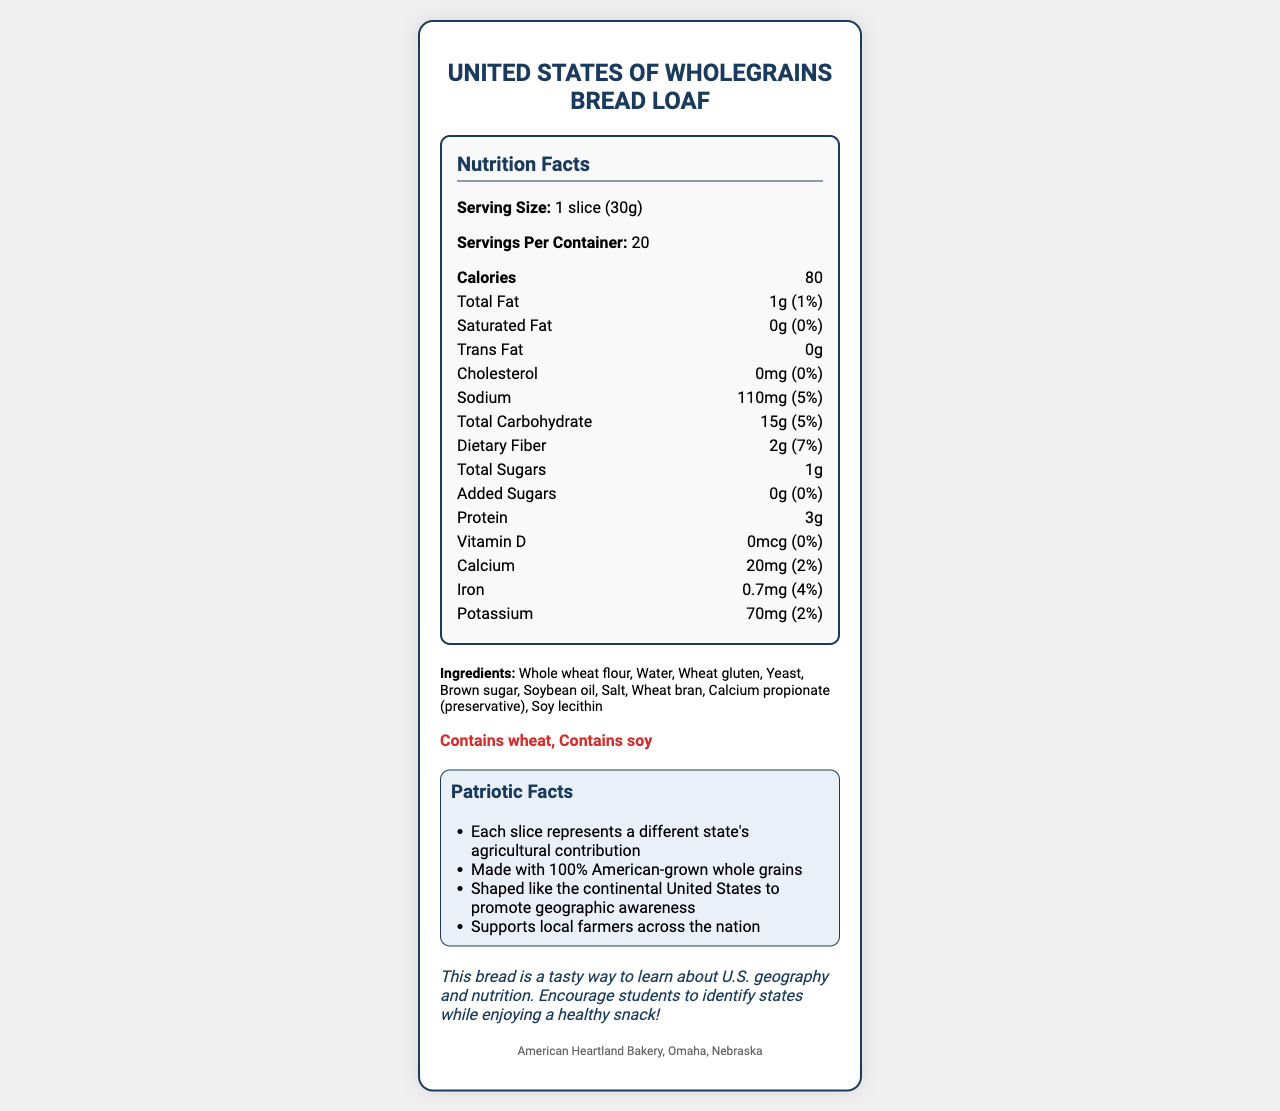what is the calorie count per serving? The Nutrition Facts section lists "Calories: 80" for a serving size of 1 slice (30g).
Answer: 80 calories how much protein is in one slice of bread? The Nutrition Facts section lists "Protein: 3g" per serving size of 1 slice (30g).
Answer: 3g what are the main ingredients of this bread? The Ingredients section lists all the main ingredients used to make the bread.
Answer: Whole wheat flour, Water, Wheat gluten, Yeast, Brown sugar, Soybean oil, Salt, Wheat bran, Calcium propionate (preservative), Soy lecithin what is the daily value percentage of dietary fiber in one slice? The Nutrition Facts section lists "Dietary Fiber: 2g (7%)" per serving size of 1 slice (30g).
Answer: 7% how much sodium does one slice contain? The Nutrition Facts section lists "Sodium: 110mg (5%)" per serving size of 1 slice (30g).
Answer: 110mg which vitamin has the highest daily value percentage in one slice of bread? A. Vitamin D B. Calcium C. Iron D. Potassium The Nutrition Facts section lists Iron with a daily value of 4%, higher than Vitamin D (0%), Calcium (2%), and Potassium (2%).
Answer: C what is the serving size of a bread slice? The Nutrition Facts section lists "Serving Size: 1 slice (30g)".
Answer: 1 slice (30g) how many servings does each bread loaf contain? The Nutrition Facts section lists "Servings Per Container: 20".
Answer: 20 are there any added sugars in this bread? The Nutrition Facts section lists "Added Sugars: 0g (0%)".
Answer: No is the bread suitable for someone with gluten intolerance? The Allergens section states that the bread "Contains wheat", and the Ingredients section lists "Whole wheat flour".
Answer: No summarize the document. The document gives an overview of the nutritional content and ingredients of the bread, emphasizing its patriotic aspect and educational value.
Answer: The document provides the Nutrition Facts, ingredients, and patriotic facts for the United States of Wholegrains Bread Loaf. It highlights the serving size, calories, and various nutritional values per serving. The bread is shaped like the continental United States, contains American-grown whole grains, and supports local farmers. It also contains allergens such as wheat and soy. can we determine the exact amount of water used in the bread from this document? The document lists "Water" as an ingredient but does not specify the exact quantity used.
Answer: Cannot be determined who is the manufacturer of this bread? The Manufacturer section at the bottom of the document states the bread is made by American Heartland Bakery based in Omaha, Nebraska.
Answer: American Heartland Bakery, Omaha, Nebraska does the bread contain any cholesterol? The Nutrition Facts section lists "Cholesterol: 0mg (0%)".
Answer: No which nutritional element has a daily value percentage of 2%? A. Vitamin D B. Calcium C. Iron D. Potassium The Nutrition Facts section lists both Calcium (20mg, 2%) and Potassium (70mg, 2%) with daily value percentages of 2%.
Answer: B and D 